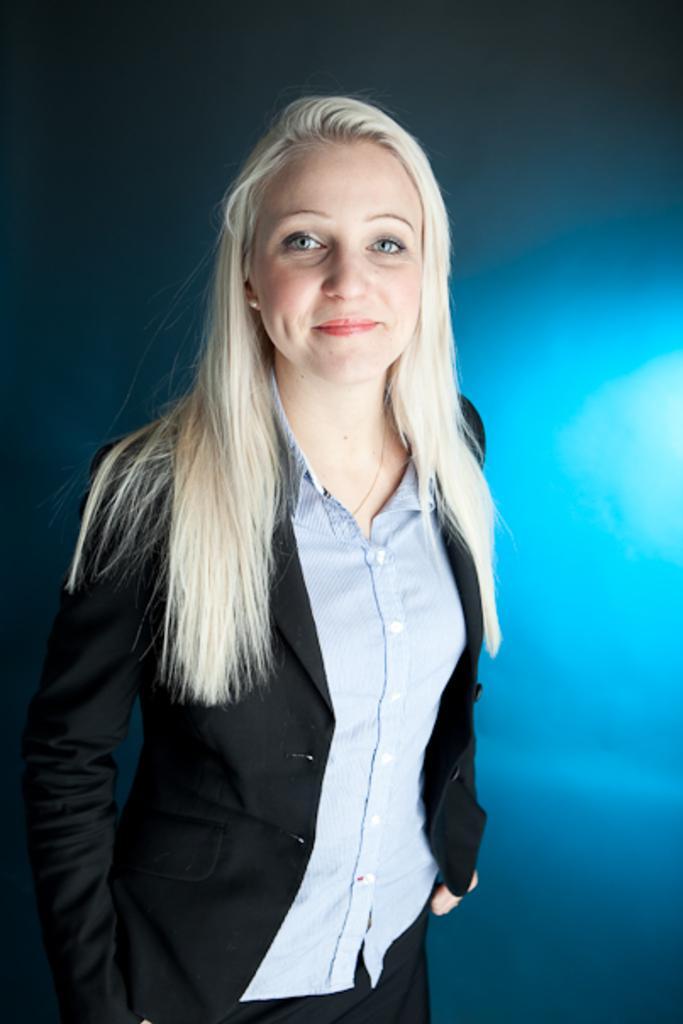Can you describe this image briefly? In this image I can see a woman standing, smiling and giving pose for the picture. It seems to be the background is edited. 